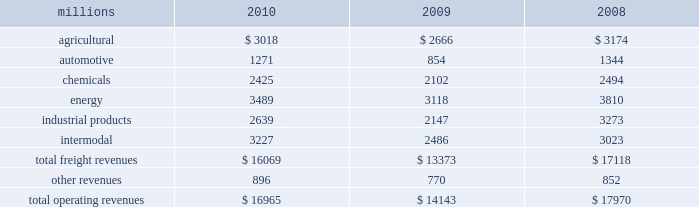Notes to the consolidated financial statements union pacific corporation and subsidiary companies for purposes of this report , unless the context otherwise requires , all references herein to the 201ccorporation 201d , 201cupc 201d , 201cwe 201d , 201cus 201d , and 201cour 201d mean union pacific corporation and its subsidiaries , including union pacific railroad company , which will be separately referred to herein as 201cuprr 201d or the 201crailroad 201d .
Nature of operations operations and segmentation 2013 we are a class i railroad that operates in the u.s .
We have 31953 route miles , linking pacific coast and gulf coast ports with the midwest and eastern u.s .
Gateways and providing several corridors to key mexican gateways .
We serve the western two-thirds of the country and maintain coordinated schedules with other rail carriers for the handling of freight to and from the atlantic coast , the pacific coast , the southeast , the southwest , canada , and mexico .
Export and import traffic is moved through gulf coast and pacific coast ports and across the mexican and canadian borders .
The railroad , along with its subsidiaries and rail affiliates , is our one reportable operating segment .
Although revenues are analyzed by commodity group , we analyze the net financial results of the railroad as one segment due to the integrated nature of our rail network .
The table provides revenue by commodity group : millions 2010 2009 2008 .
Although our revenues are principally derived from customers domiciled in the u.s. , the ultimate points of origination or destination for some products transported are outside the u.s .
Basis of presentation 2013 the consolidated financial statements are presented in accordance with accounting principles generally accepted in the u.s .
( gaap ) as codified in the financial accounting standards board ( fasb ) accounting standards codification ( asc ) .
Significant accounting policies principles of consolidation 2013 the consolidated financial statements include the accounts of union pacific corporation and all of its subsidiaries .
Investments in affiliated companies ( 20% ( 20 % ) to 50% ( 50 % ) owned ) are accounted for using the equity method of accounting .
All intercompany transactions are eliminated .
We currently have no less than majority-owned investments that require consolidation under variable interest entity requirements .
Cash and cash equivalents 2013 cash equivalents consist of investments with original maturities of three months or less .
Accounts receivable 2013 accounts receivable includes receivables reduced by an allowance for doubtful accounts .
The allowance is based upon historical losses , credit worthiness of customers , and current economic conditions .
Receivables not expected to be collected in one year and the associated allowances are classified as other assets in our consolidated statements of financial position .
Investments 2013 investments represent our investments in affiliated companies ( 20% ( 20 % ) to 50% ( 50 % ) owned ) that are accounted for under the equity method of accounting and investments in companies ( less than 20% ( 20 % ) owned ) accounted for under the cost method of accounting. .
From 2008 to 2010 what was the average revenues by commodity group from agriculture? 
Computations: (((3018 + 2666) + 3174) / 3)
Answer: 2952.66667. 